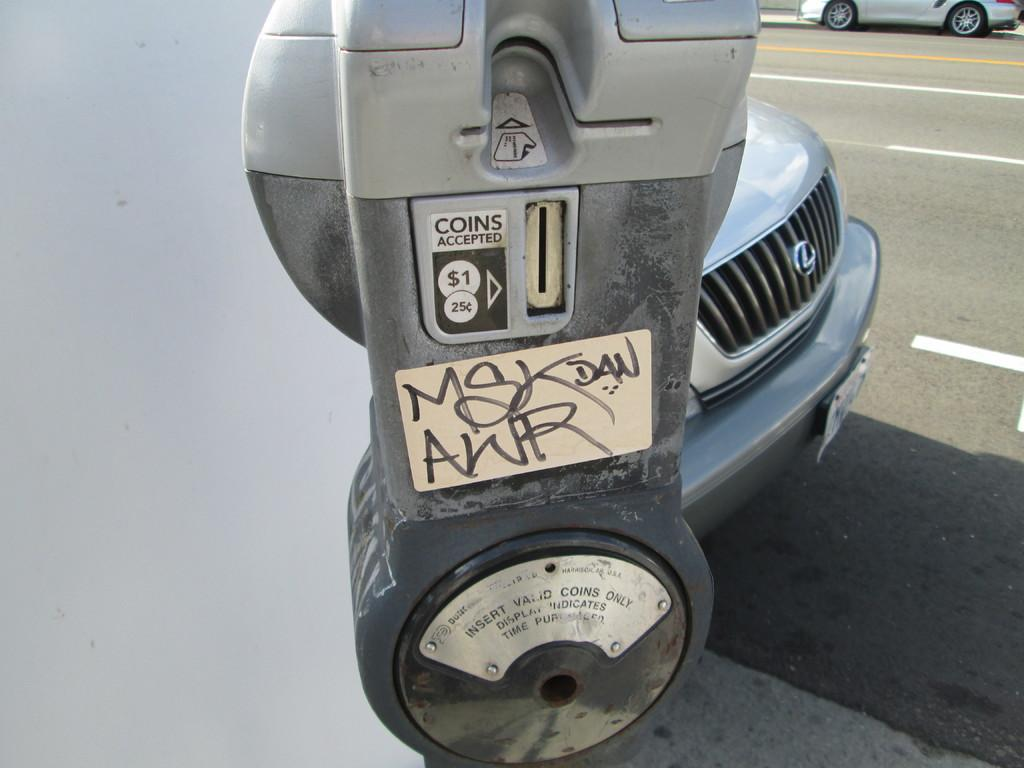<image>
Present a compact description of the photo's key features. A single parking meter which accepts valid coins only. 